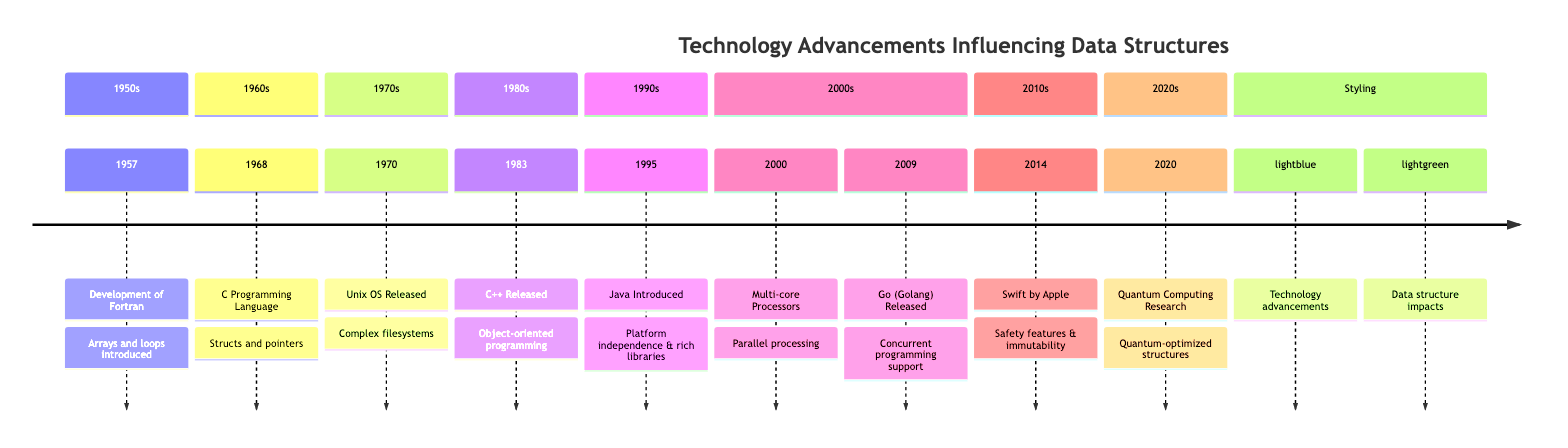What year was Fortran developed? Fortran was developed in 1957, as indicated in the timeline.
Answer: 1957 What programming language was introduced in 1968? The timeline shows that the C Programming Language was introduced in 1968.
Answer: C Programming Language Which technology advancement introduced objects and encapsulation? The introduction of C++ in 1983 brought object-oriented programming, which introduced classes and objects for encapsulation.
Answer: C++ How many advancements are listed in the 2000s section? The timeline shows two advancements in the 2000s: the emergence of multi-core processors in 2000 and the release of Go in 2009.
Answer: 2 Which programming language influenced quantum-optimized data structures? According to the timeline, the widespread adoption of Quantum Computing research in 2020 begins to influence the conceptualization of data structures.
Answer: Quantum Computing Research In which decade was the Unix Operating System released? The timeline lists the release of the Unix Operating System in 1970, which falls in the 1970s.
Answer: 1970s What is the primary benefit of Java introduced in 1995? The timeline describes Java as offering platform independence with its virtual machine and a rich standard library.
Answer: Platform independence Which data structure concept was emphasized in Swift introduced in 2014? The timeline indicates that Swift introduced safety features, which promote immutability in data structure implementations.
Answer: Safety features Compare the years of the release of C++ and Java. C++ was released in 1983, while Java was introduced in 1995, indicating that C++ predates Java by 12 years.
Answer: 12 years What is a key feature of Go (Golang) introduced in 2009? The timeline highlights Go's built-in support for concurrent programming as a key feature influencing modern data structures.
Answer: Concurrent programming support 